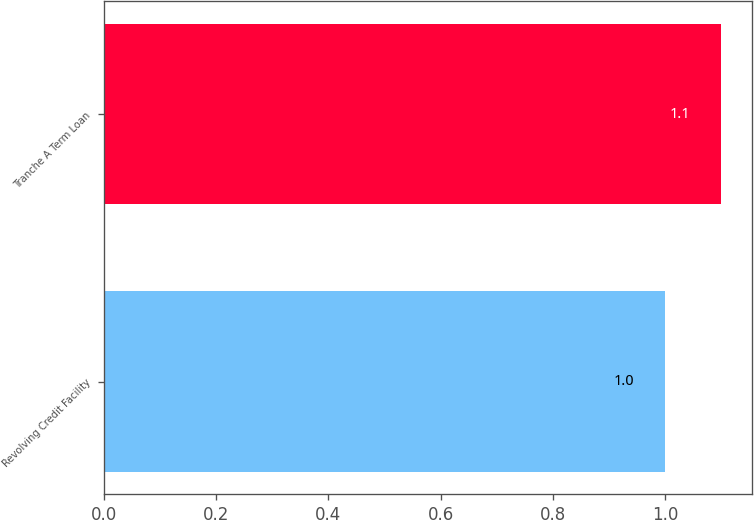<chart> <loc_0><loc_0><loc_500><loc_500><bar_chart><fcel>Revolving Credit Facility<fcel>Tranche A Term Loan<nl><fcel>1<fcel>1.1<nl></chart> 